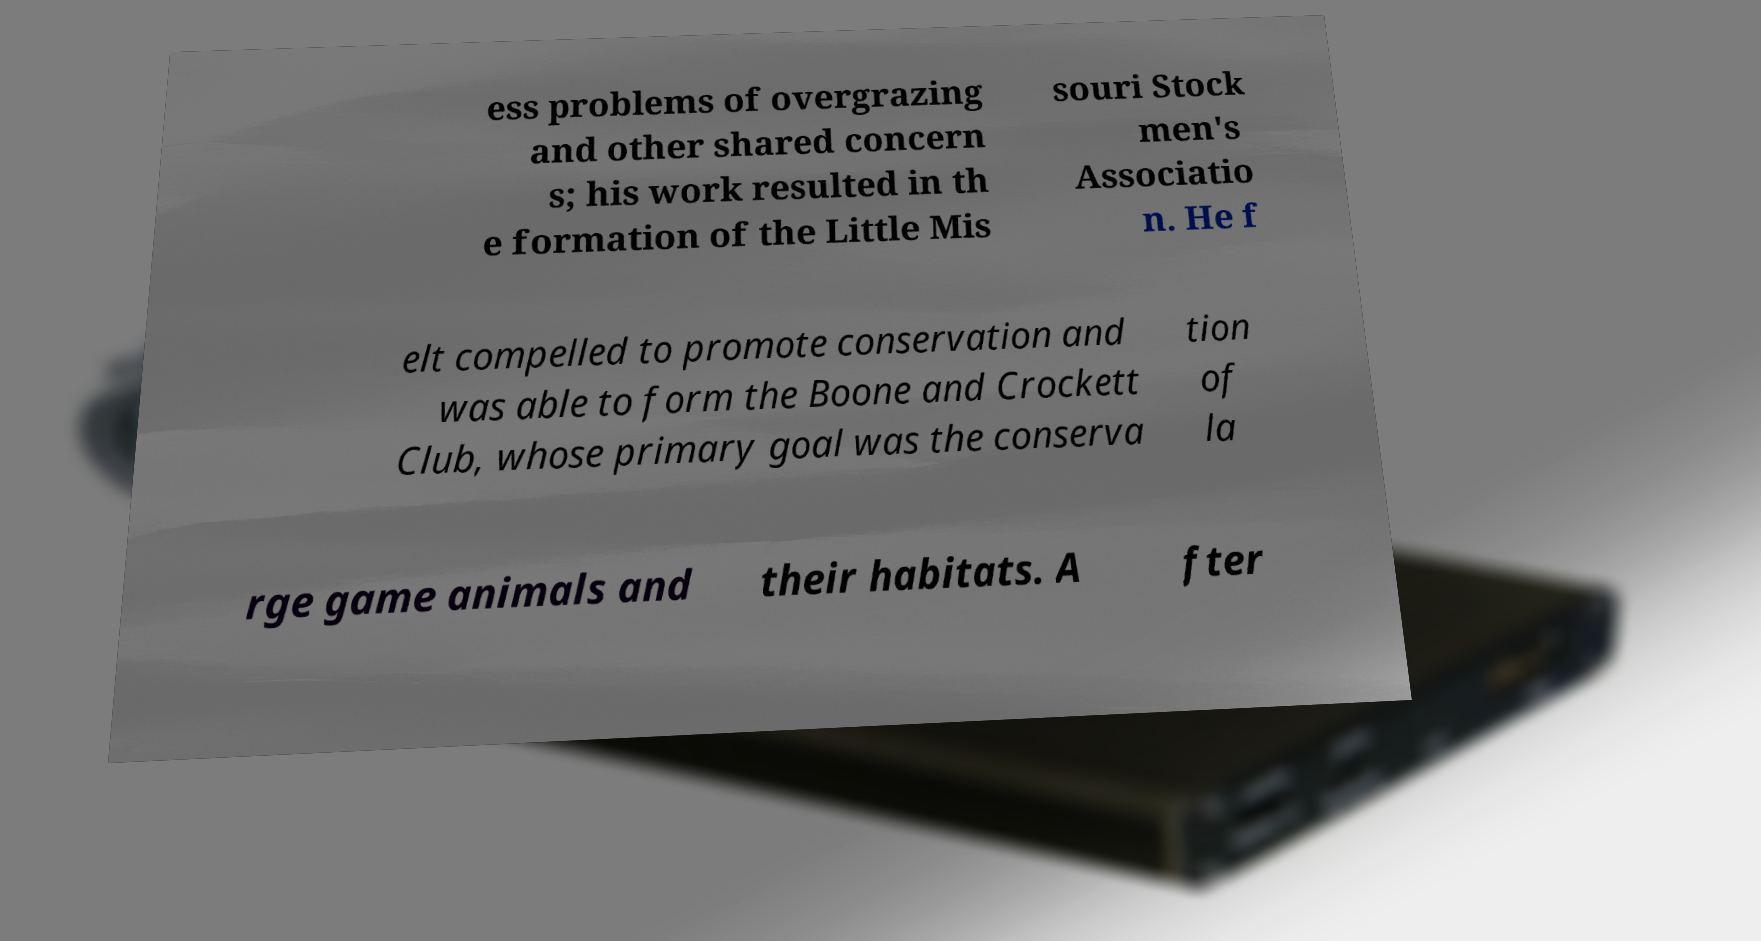There's text embedded in this image that I need extracted. Can you transcribe it verbatim? ess problems of overgrazing and other shared concern s; his work resulted in th e formation of the Little Mis souri Stock men's Associatio n. He f elt compelled to promote conservation and was able to form the Boone and Crockett Club, whose primary goal was the conserva tion of la rge game animals and their habitats. A fter 